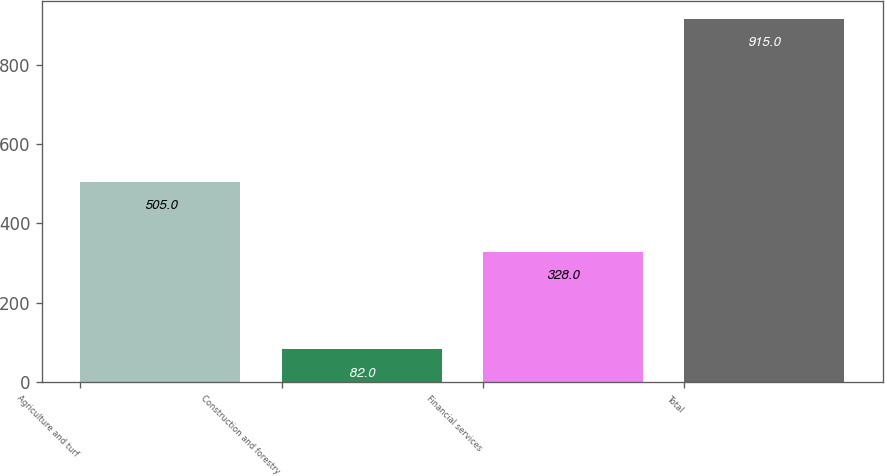Convert chart to OTSL. <chart><loc_0><loc_0><loc_500><loc_500><bar_chart><fcel>Agriculture and turf<fcel>Construction and forestry<fcel>Financial services<fcel>Total<nl><fcel>505<fcel>82<fcel>328<fcel>915<nl></chart> 